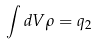Convert formula to latex. <formula><loc_0><loc_0><loc_500><loc_500>\int d V \rho = q _ { 2 }</formula> 